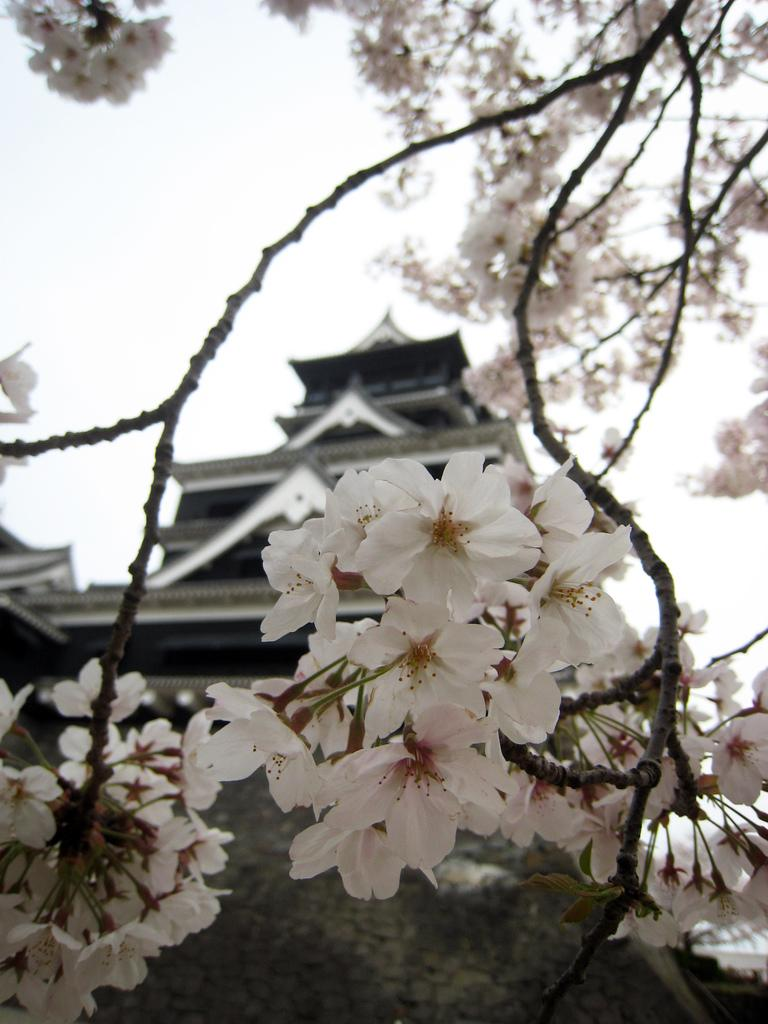What is present on the branches of the tree in the image? There is a group of flowers on the branches of a tree in the image. What type of structure can be seen in the background of the image? There is a building with a roof in the background of the image. What part of the natural environment is visible in the image? The sky is visible in the background of the image. Where is the veil located in the image? There is no veil present in the image. What type of fruit can be seen hanging from the branches of the tree? The image does not show any fruit hanging from the branches of the tree; it only shows flowers. 